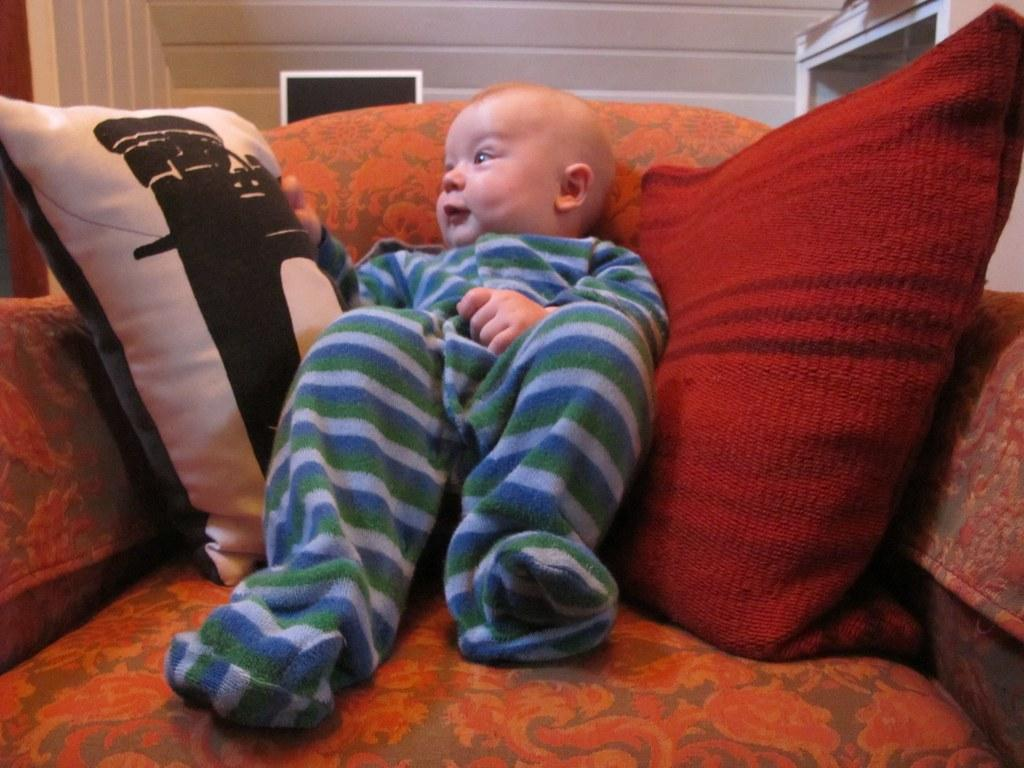What is the main subject of the image? The main subject of the image is a kid. What is the kid doing in the image? The kid is sitting on a sofa. What can be seen in the background of the image? There is a wall in the background of the image. What type of jail can be seen in the image? There is no jail present in the image; it features a kid sitting on a sofa with a wall in the background. 